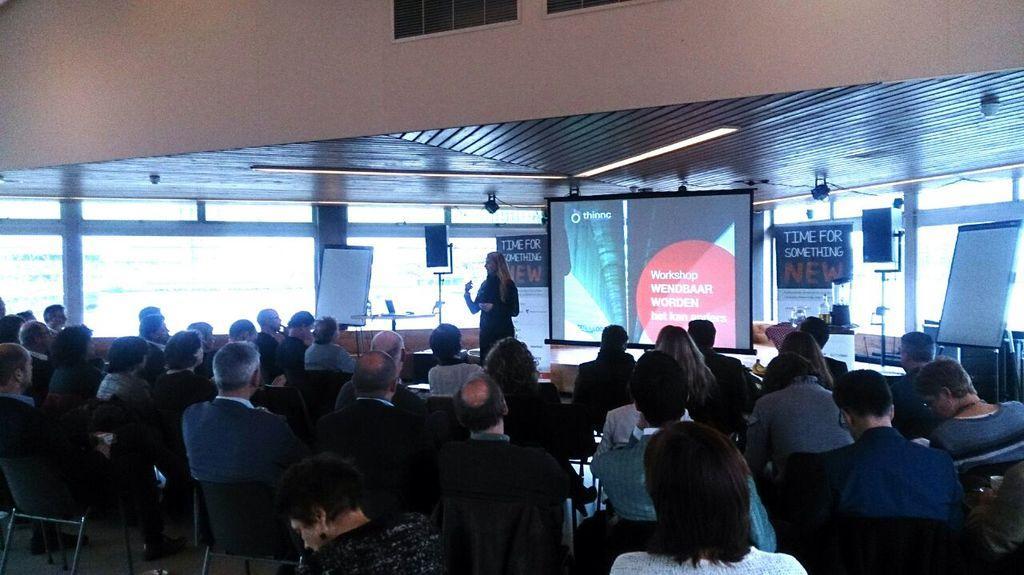Please provide a concise description of this image. In this image there are group of people sitting, and in the center there is one woman standing and talking. And also there are some boards, and screen. On the boards there is text, and on the screen there is text and in the background there are glass windows and some objects. At the top there is ceiling, and at the top of the image there are windows. 